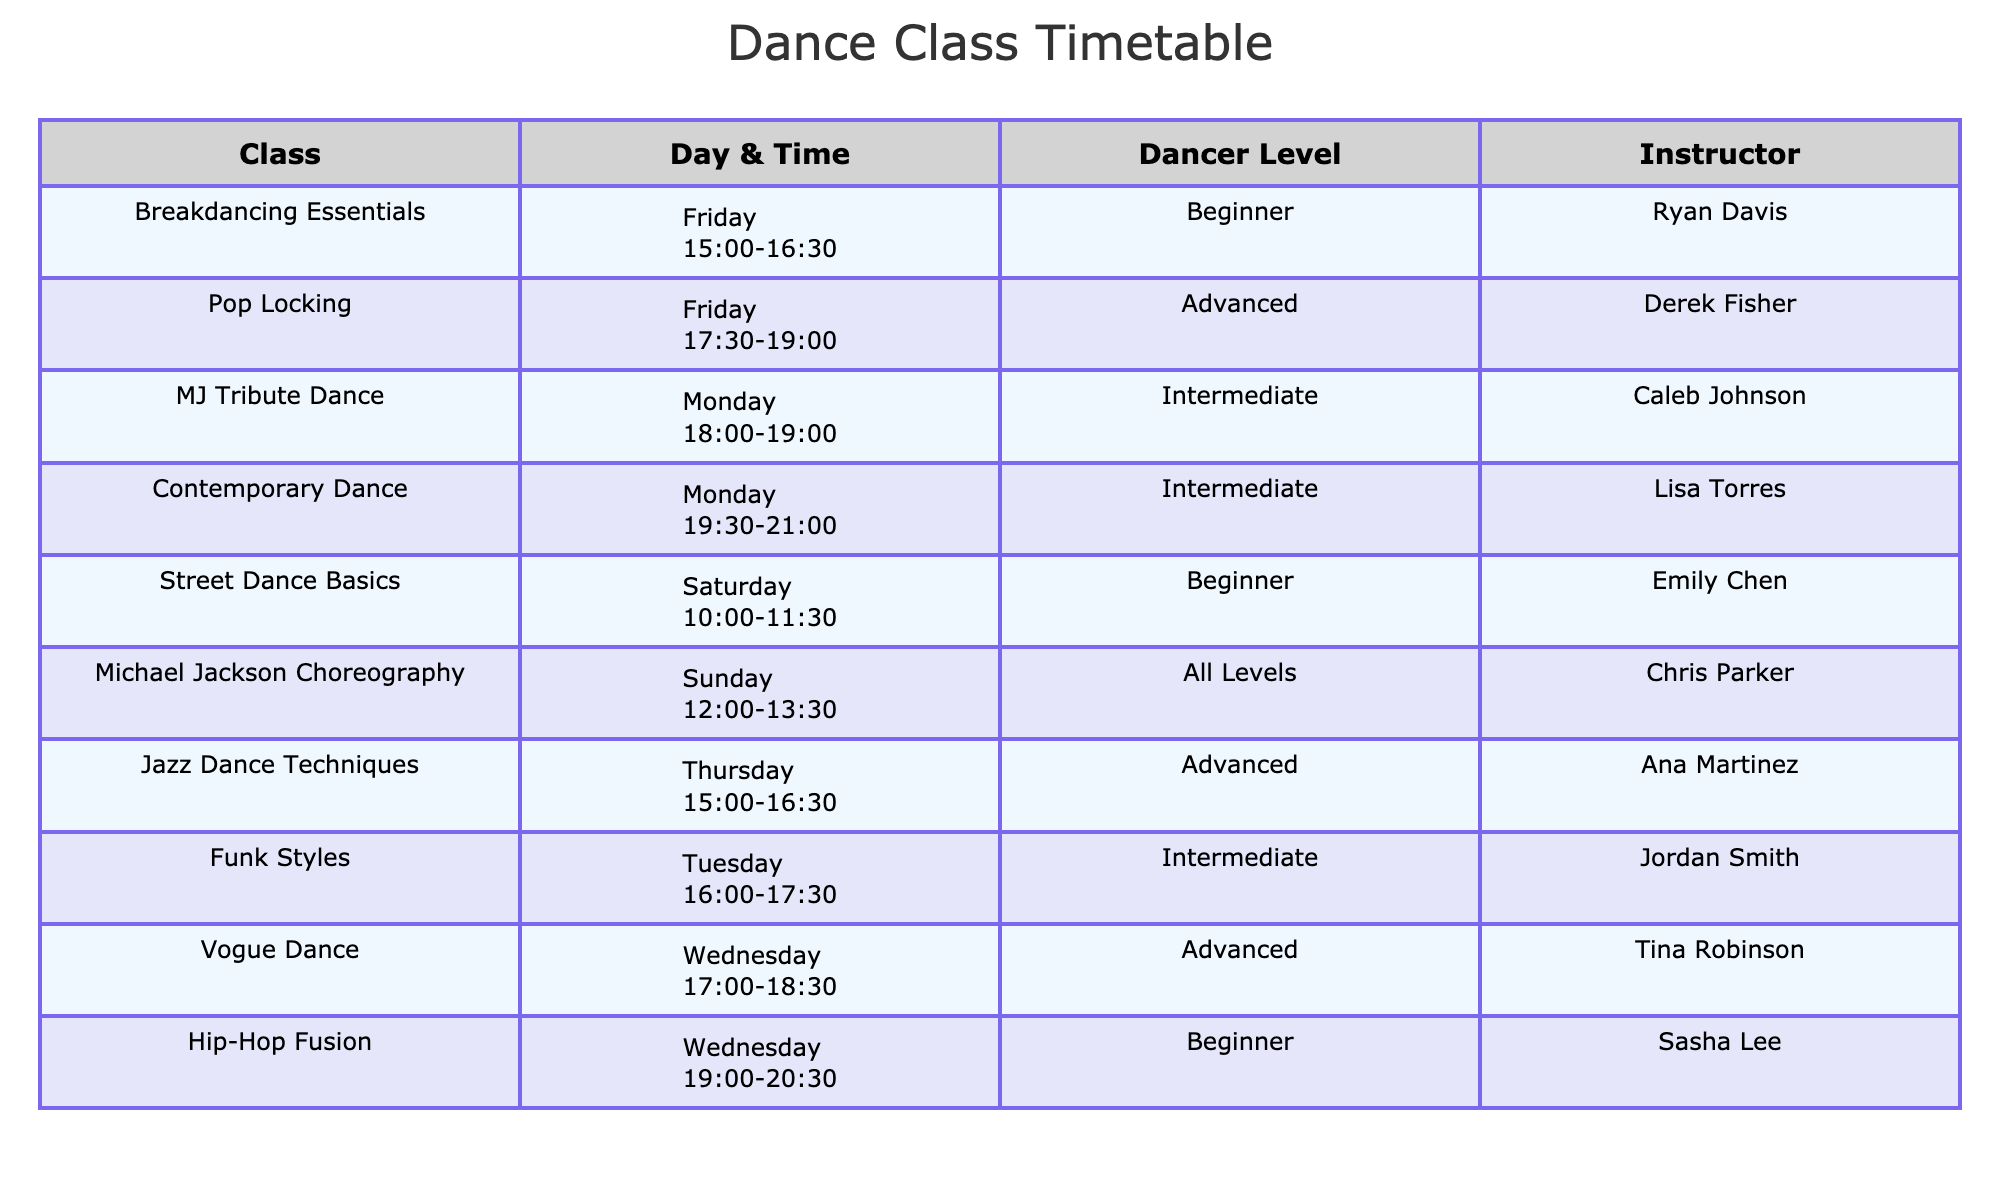What dance class is taught by Chris Parker? The table indicates that the class taught by Chris Parker is "Michael Jackson Choreography." This can be directly located in the "Instructor" column corresponding to "Michael Jackson Choreography" in the "Class" column.
Answer: Michael Jackson Choreography What are the dancer levels offered on Fridays? Looking at the table, there are two classes on Fridays: "Pop Locking" with an Advanced dancer level and "Breakdancing Essentials" with a Beginner dancer level. Hence, the levels offered on Fridays are Advanced and Beginner.
Answer: Advanced, Beginner Is there a Jazz Dance class on Thursday? According to the table, there is indeed a class titled "Jazz Dance Techniques" scheduled for Thursday. This confirms that there is a Jazz Dance class on that day.
Answer: Yes How many classes are offered at an Intermediate level? From the table, the classes listed as Intermediate are "MJ Tribute Dance," "Funk Styles," and "Contemporary Dance." Thus, there are a total of three classes at the Intermediate level.
Answer: 3 Which day has the most dance classes listed? By examining the table, each day is checked: Monday has 2 classes (MJ Tribute Dance and Contemporary Dance), Wednesday has 2 classes (Hip-Hop Fusion and Vogue Dance), Friday has 2 classes (Pop Locking and Breakdancing Essentials), Saturday has 1 class, Tuesday has 1 class, Thursday has 1 class, and Sunday has 1 class. The maximum is 2, recorded on Monday, Wednesday, and Friday.
Answer: Monday, Wednesday, Friday 